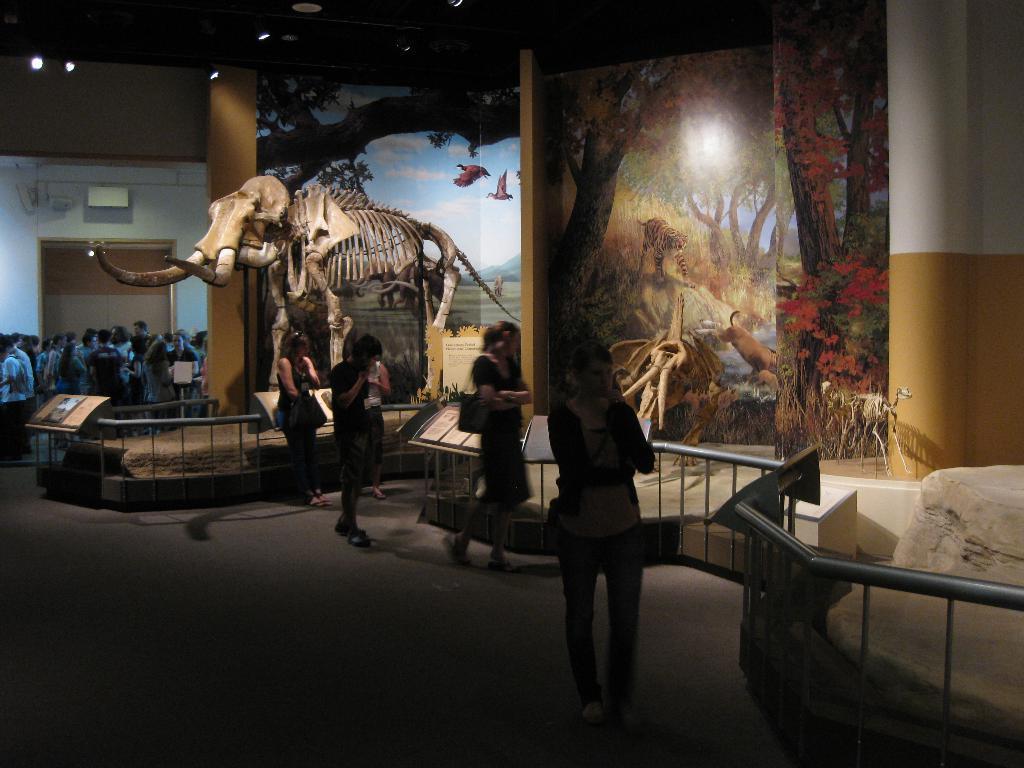In one or two sentences, can you explain what this image depicts? In this picture I can see in the middle few persons are walking, it looks like a museum, there are animals skeletons. In the background there are pictures on the wall, on the left side a group of people are there. At the top there are ceiling lights. 